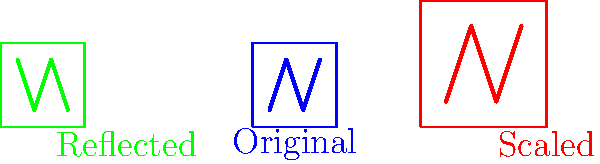In the diagram, Miles Kane's band logo is shown in three different forms: original (blue), scaled (red), and reflected (green). If the original logo has a width of 2 units, what is the combined width of all three logos? To solve this problem, let's break it down step-by-step:

1. Original logo (blue):
   - Width = 2 units

2. Scaled logo (red):
   - Scaling factor = 1.5
   - New width = Original width × Scaling factor
   - New width = 2 × 1.5 = 3 units

3. Reflected logo (green):
   - Reflection does not change the size
   - Width of reflected logo = Original width = 2 units

4. Calculate the total width:
   - Total width = Original width + Scaled width + Reflected width
   - Total width = 2 + 3 + 2 = 7 units

Therefore, the combined width of all three logos is 7 units.
Answer: 7 units 